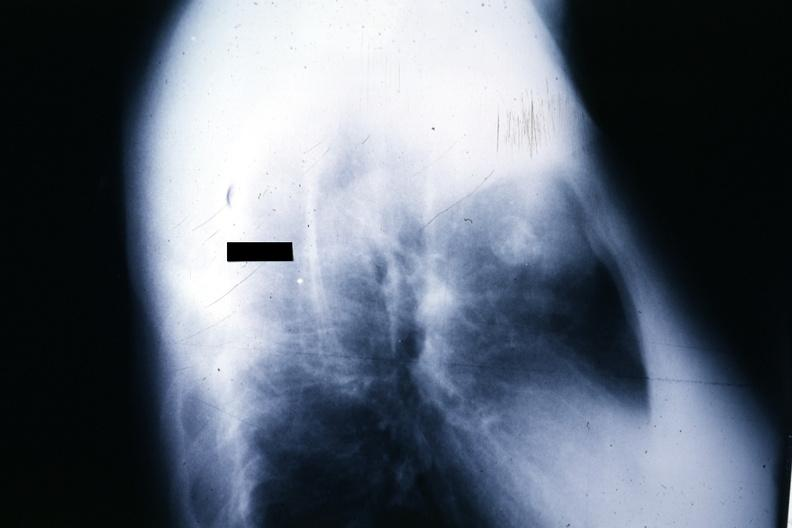what is present?
Answer the question using a single word or phrase. Thymoma 